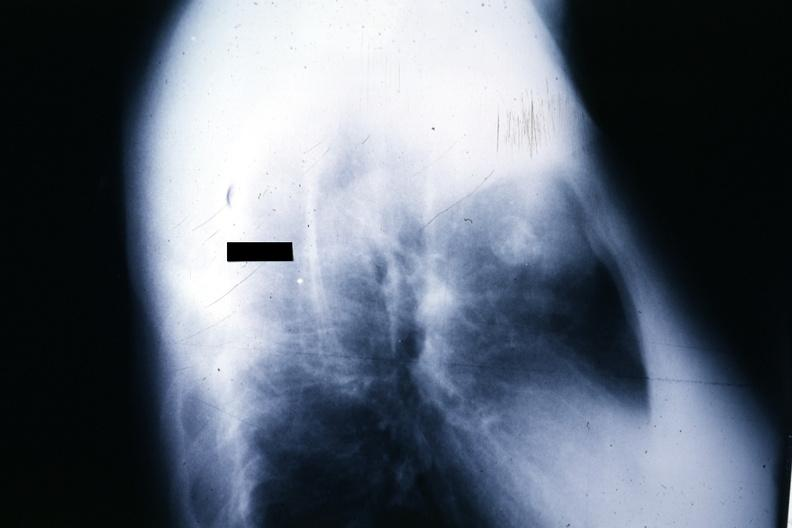what is present?
Answer the question using a single word or phrase. Thymoma 